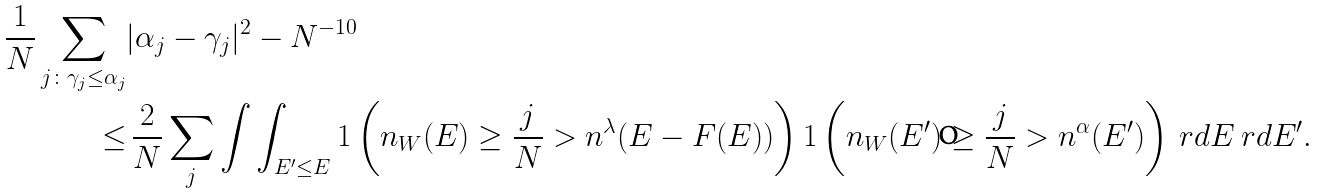Convert formula to latex. <formula><loc_0><loc_0><loc_500><loc_500>\frac { 1 } { N } \sum _ { j \colon \gamma _ { j } \leq \alpha _ { j } } & | \alpha _ { j } - \gamma _ { j } | ^ { 2 } - N ^ { - 1 0 } \\ \leq & \, \frac { 2 } { N } \sum _ { j } \int \int _ { E ^ { \prime } \leq E } { 1 } \left ( n _ { W } ( E ) \geq \frac { j } { N } > n ^ { \lambda } ( E - F ( E ) ) \right ) { 1 } \left ( n _ { W } ( E ^ { \prime } ) \geq \frac { j } { N } > n ^ { \alpha } ( E ^ { \prime } ) \right ) \ r d E \ r d E ^ { \prime } .</formula> 